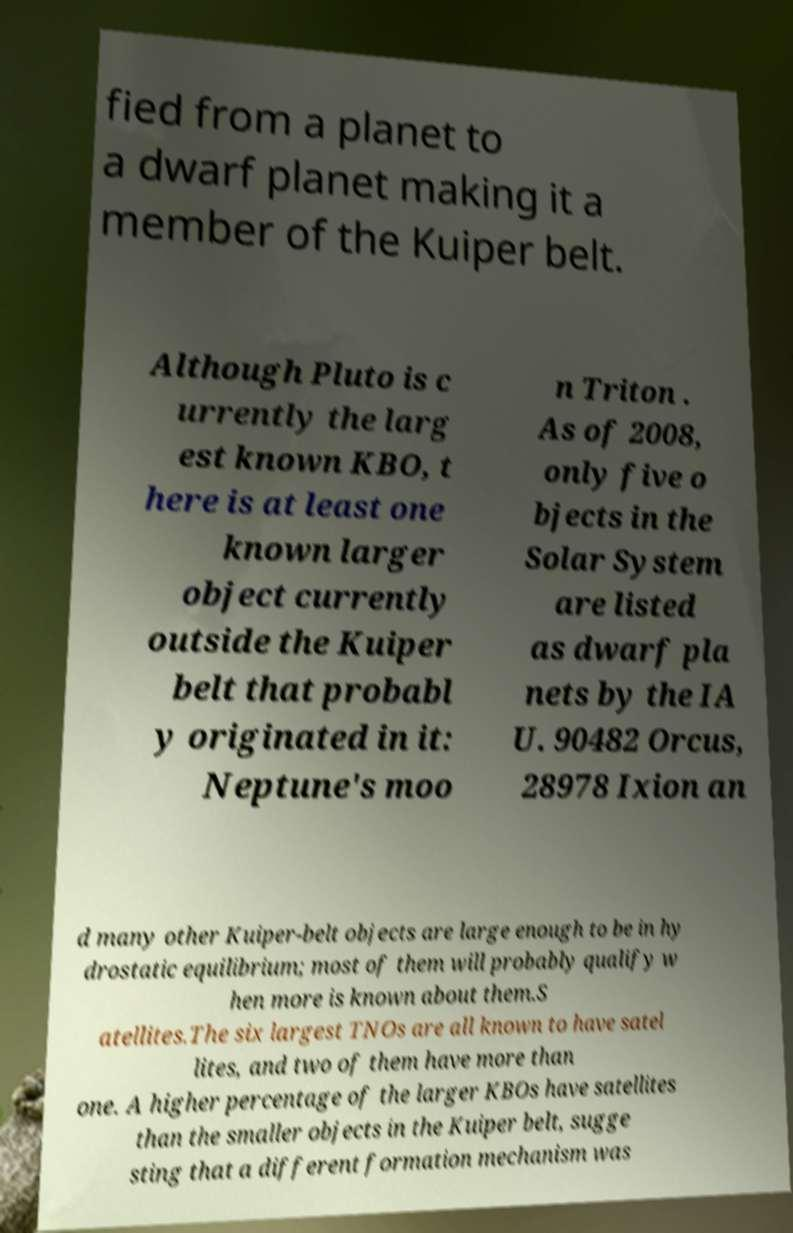Can you accurately transcribe the text from the provided image for me? fied from a planet to a dwarf planet making it a member of the Kuiper belt. Although Pluto is c urrently the larg est known KBO, t here is at least one known larger object currently outside the Kuiper belt that probabl y originated in it: Neptune's moo n Triton . As of 2008, only five o bjects in the Solar System are listed as dwarf pla nets by the IA U. 90482 Orcus, 28978 Ixion an d many other Kuiper-belt objects are large enough to be in hy drostatic equilibrium; most of them will probably qualify w hen more is known about them.S atellites.The six largest TNOs are all known to have satel lites, and two of them have more than one. A higher percentage of the larger KBOs have satellites than the smaller objects in the Kuiper belt, sugge sting that a different formation mechanism was 